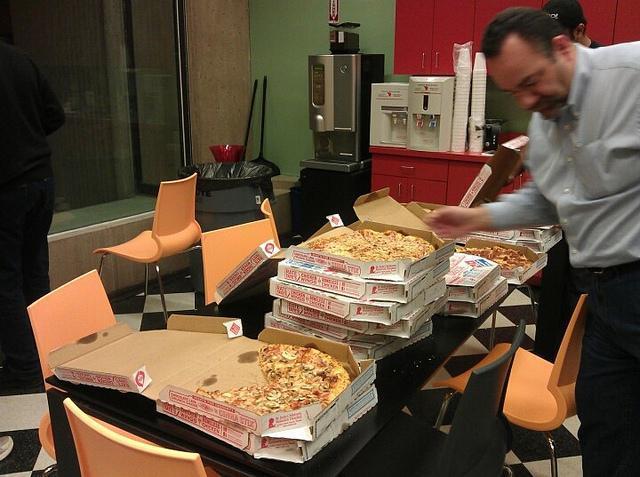How many pizza boxes?
Give a very brief answer. 11. How many slices of pizza are missing?
Give a very brief answer. 2. How many people are visible?
Give a very brief answer. 2. How many chairs are there?
Give a very brief answer. 6. How many pizzas are there?
Give a very brief answer. 2. 